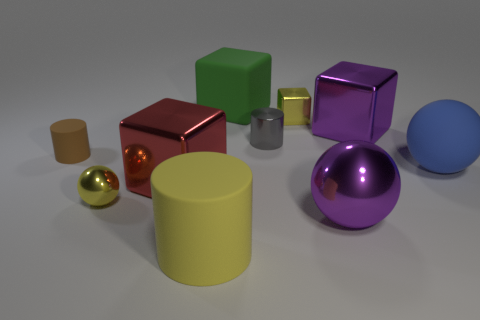What emotions could this image evoke in a viewer? The image might evoke feelings of curiosity or intrigue due to the variety of colors and shapes. It can also provide a sense of calmness and order, as the objects are neatly arranged and the scene is clean and uncluttered. The play of light and reflection could also elicit an appreciation for simple beauty in everyday objects. 